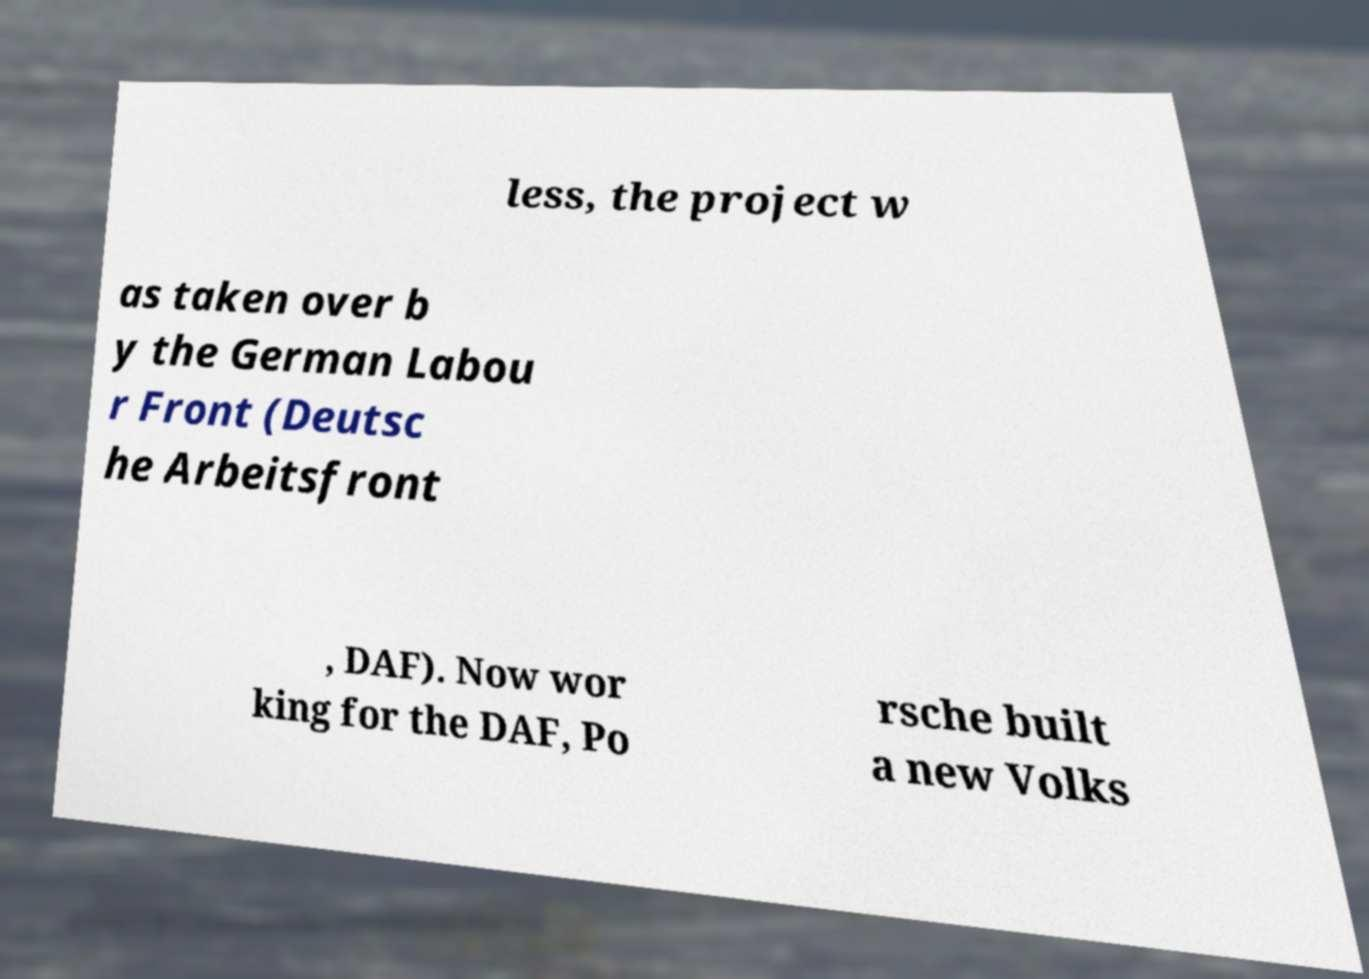Could you extract and type out the text from this image? less, the project w as taken over b y the German Labou r Front (Deutsc he Arbeitsfront , DAF). Now wor king for the DAF, Po rsche built a new Volks 